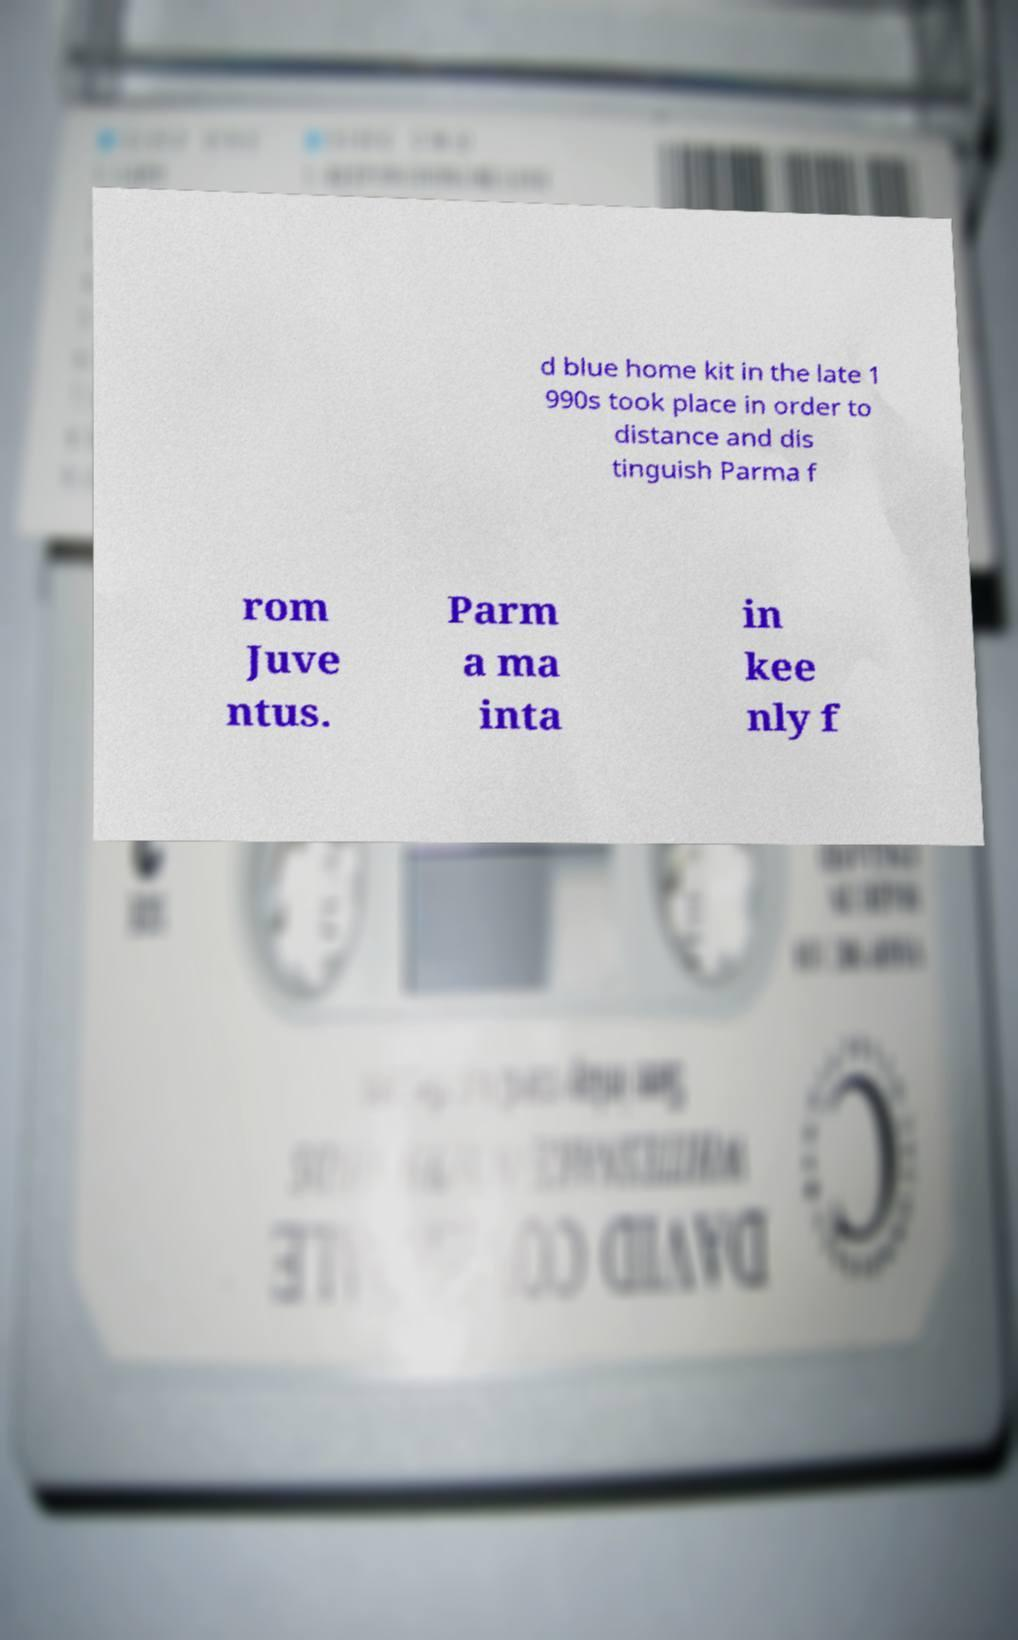What messages or text are displayed in this image? I need them in a readable, typed format. d blue home kit in the late 1 990s took place in order to distance and dis tinguish Parma f rom Juve ntus. Parm a ma inta in kee nly f 